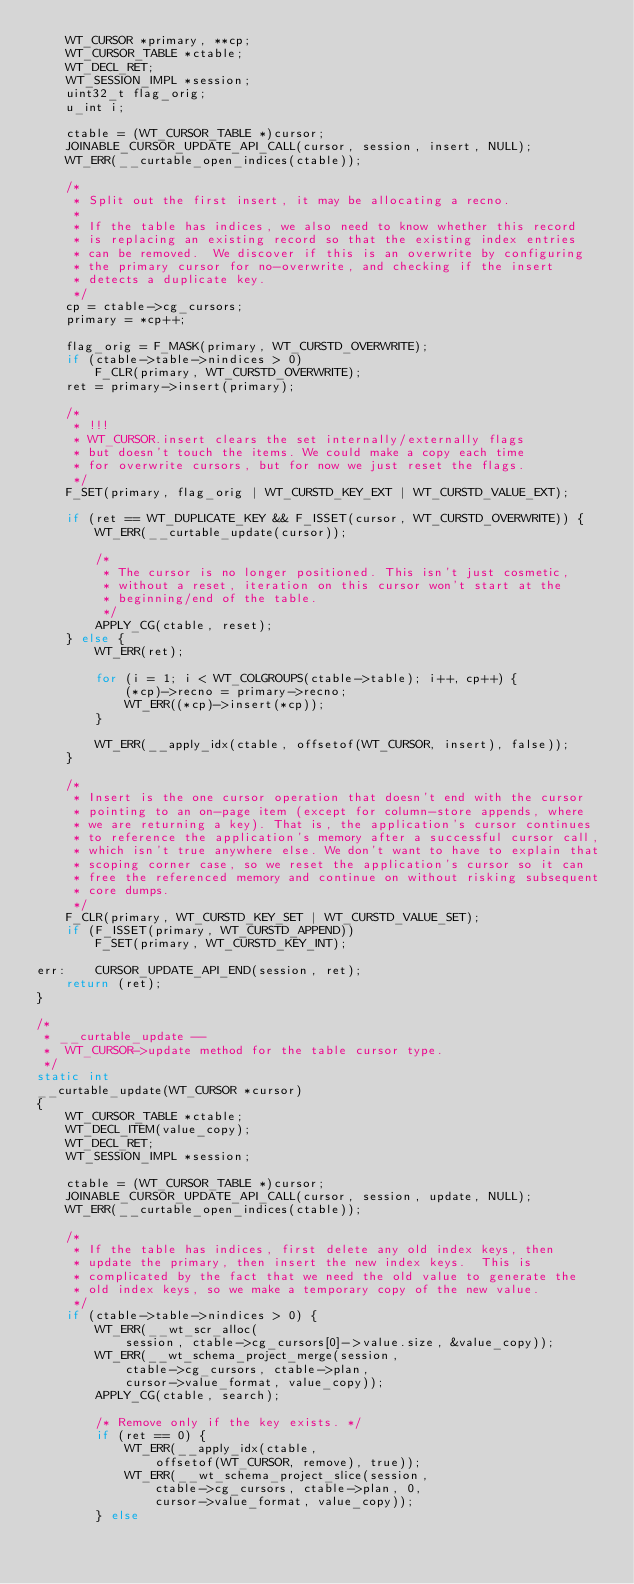Convert code to text. <code><loc_0><loc_0><loc_500><loc_500><_C_>	WT_CURSOR *primary, **cp;
	WT_CURSOR_TABLE *ctable;
	WT_DECL_RET;
	WT_SESSION_IMPL *session;
	uint32_t flag_orig;
	u_int i;

	ctable = (WT_CURSOR_TABLE *)cursor;
	JOINABLE_CURSOR_UPDATE_API_CALL(cursor, session, insert, NULL);
	WT_ERR(__curtable_open_indices(ctable));

	/*
	 * Split out the first insert, it may be allocating a recno.
	 *
	 * If the table has indices, we also need to know whether this record
	 * is replacing an existing record so that the existing index entries
	 * can be removed.  We discover if this is an overwrite by configuring
	 * the primary cursor for no-overwrite, and checking if the insert
	 * detects a duplicate key.
	 */
	cp = ctable->cg_cursors;
	primary = *cp++;

	flag_orig = F_MASK(primary, WT_CURSTD_OVERWRITE);
	if (ctable->table->nindices > 0)
		F_CLR(primary, WT_CURSTD_OVERWRITE);
	ret = primary->insert(primary);

	/*
	 * !!!
	 * WT_CURSOR.insert clears the set internally/externally flags
	 * but doesn't touch the items. We could make a copy each time
	 * for overwrite cursors, but for now we just reset the flags.
	 */
	F_SET(primary, flag_orig | WT_CURSTD_KEY_EXT | WT_CURSTD_VALUE_EXT);

	if (ret == WT_DUPLICATE_KEY && F_ISSET(cursor, WT_CURSTD_OVERWRITE)) {
		WT_ERR(__curtable_update(cursor));

		/*
		 * The cursor is no longer positioned. This isn't just cosmetic,
		 * without a reset, iteration on this cursor won't start at the
		 * beginning/end of the table.
		 */
		APPLY_CG(ctable, reset);
	} else {
		WT_ERR(ret);

		for (i = 1; i < WT_COLGROUPS(ctable->table); i++, cp++) {
			(*cp)->recno = primary->recno;
			WT_ERR((*cp)->insert(*cp));
		}

		WT_ERR(__apply_idx(ctable, offsetof(WT_CURSOR, insert), false));
	}

	/*
	 * Insert is the one cursor operation that doesn't end with the cursor
	 * pointing to an on-page item (except for column-store appends, where
	 * we are returning a key). That is, the application's cursor continues
	 * to reference the application's memory after a successful cursor call,
	 * which isn't true anywhere else. We don't want to have to explain that
	 * scoping corner case, so we reset the application's cursor so it can
	 * free the referenced memory and continue on without risking subsequent
	 * core dumps.
	 */
	F_CLR(primary, WT_CURSTD_KEY_SET | WT_CURSTD_VALUE_SET);
	if (F_ISSET(primary, WT_CURSTD_APPEND))
		F_SET(primary, WT_CURSTD_KEY_INT);

err:	CURSOR_UPDATE_API_END(session, ret);
	return (ret);
}

/*
 * __curtable_update --
 *	WT_CURSOR->update method for the table cursor type.
 */
static int
__curtable_update(WT_CURSOR *cursor)
{
	WT_CURSOR_TABLE *ctable;
	WT_DECL_ITEM(value_copy);
	WT_DECL_RET;
	WT_SESSION_IMPL *session;

	ctable = (WT_CURSOR_TABLE *)cursor;
	JOINABLE_CURSOR_UPDATE_API_CALL(cursor, session, update, NULL);
	WT_ERR(__curtable_open_indices(ctable));

	/*
	 * If the table has indices, first delete any old index keys, then
	 * update the primary, then insert the new index keys.  This is
	 * complicated by the fact that we need the old value to generate the
	 * old index keys, so we make a temporary copy of the new value.
	 */
	if (ctable->table->nindices > 0) {
		WT_ERR(__wt_scr_alloc(
		    session, ctable->cg_cursors[0]->value.size, &value_copy));
		WT_ERR(__wt_schema_project_merge(session,
		    ctable->cg_cursors, ctable->plan,
		    cursor->value_format, value_copy));
		APPLY_CG(ctable, search);

		/* Remove only if the key exists. */
		if (ret == 0) {
			WT_ERR(__apply_idx(ctable,
			    offsetof(WT_CURSOR, remove), true));
			WT_ERR(__wt_schema_project_slice(session,
			    ctable->cg_cursors, ctable->plan, 0,
			    cursor->value_format, value_copy));
		} else</code> 